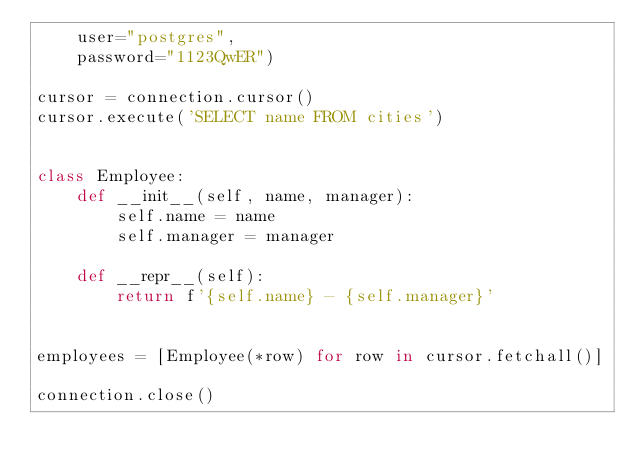Convert code to text. <code><loc_0><loc_0><loc_500><loc_500><_Python_>    user="postgres",
    password="1123QwER")

cursor = connection.cursor()
cursor.execute('SELECT name FROM cities')


class Employee:
    def __init__(self, name, manager):
        self.name = name
        self.manager = manager

    def __repr__(self):
        return f'{self.name} - {self.manager}'


employees = [Employee(*row) for row in cursor.fetchall()]

connection.close()
</code> 